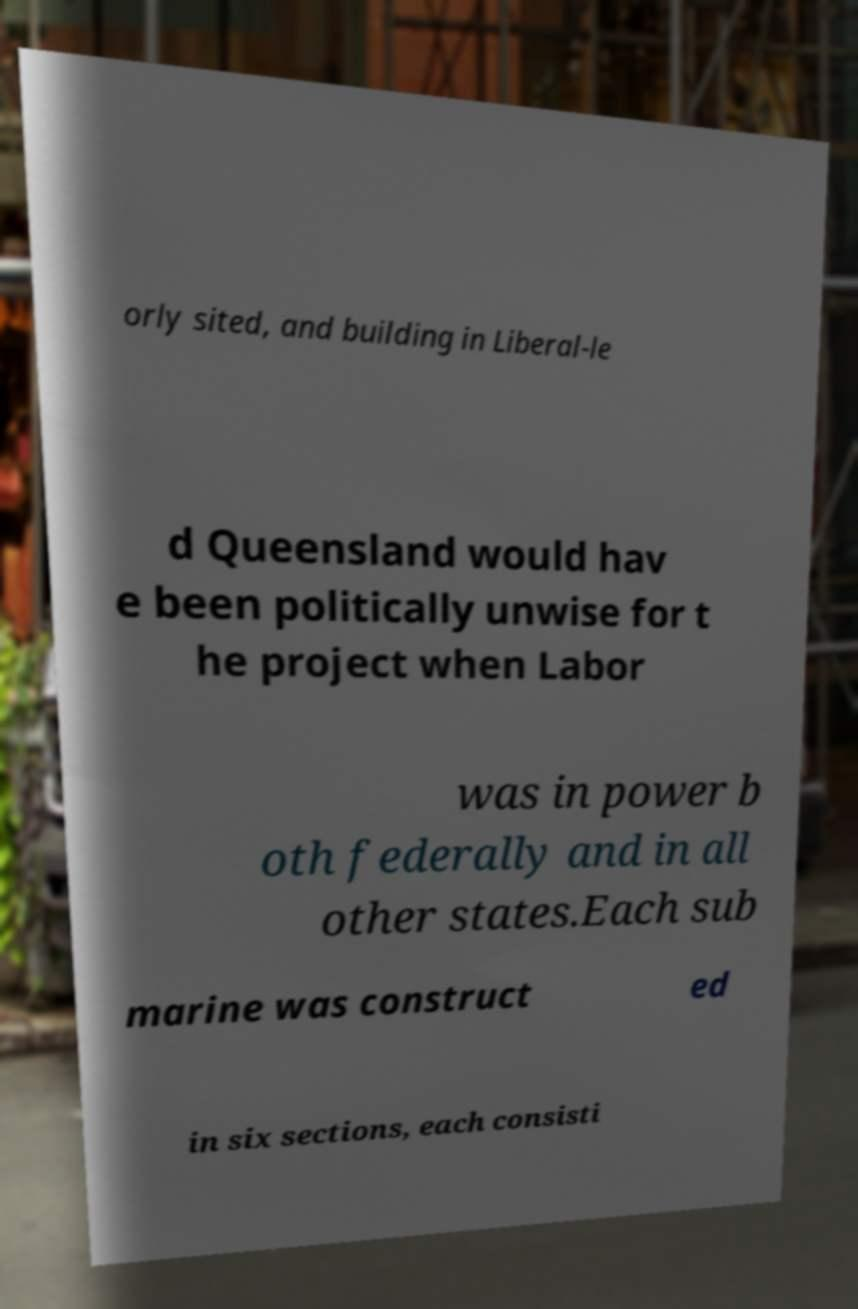Please read and relay the text visible in this image. What does it say? orly sited, and building in Liberal-le d Queensland would hav e been politically unwise for t he project when Labor was in power b oth federally and in all other states.Each sub marine was construct ed in six sections, each consisti 